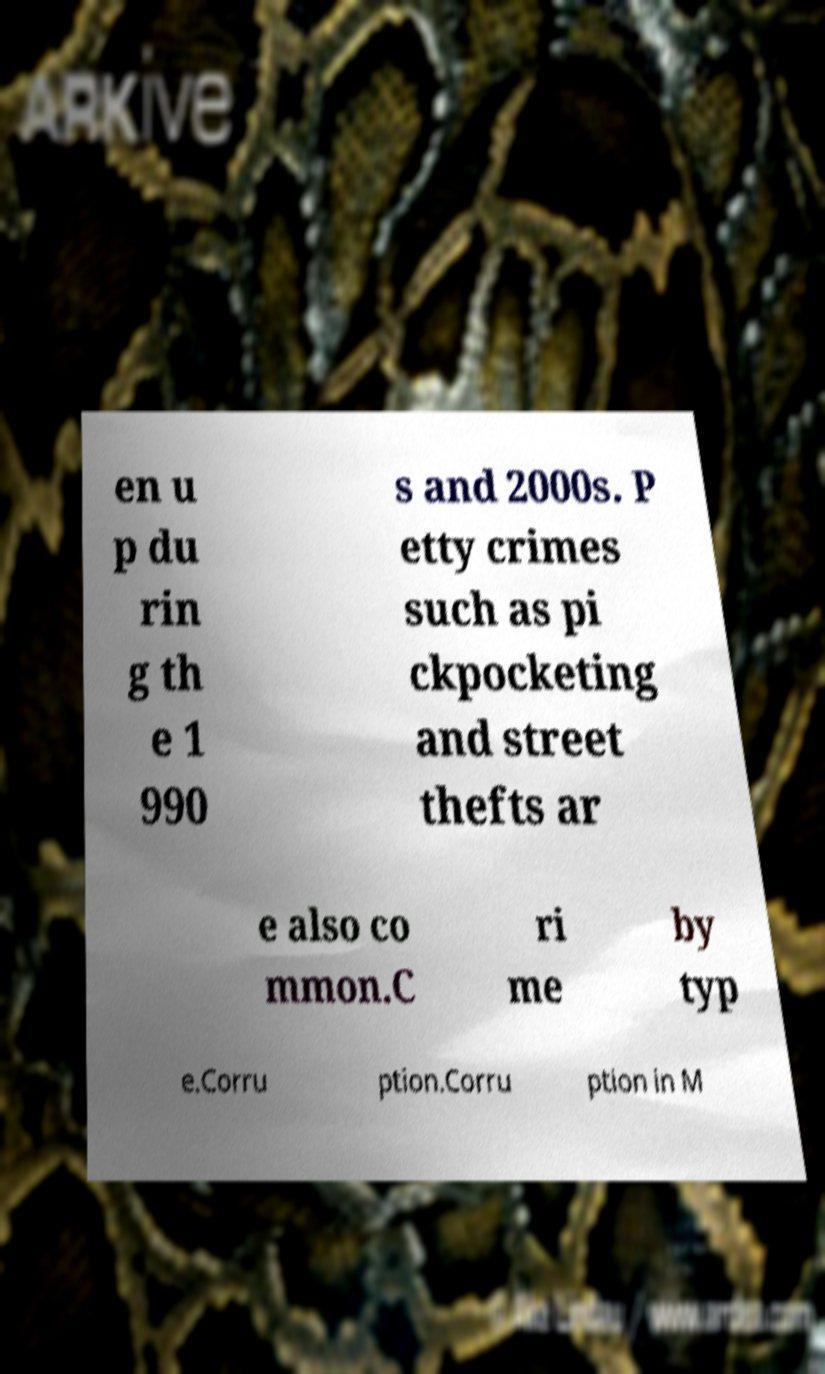Can you read and provide the text displayed in the image?This photo seems to have some interesting text. Can you extract and type it out for me? en u p du rin g th e 1 990 s and 2000s. P etty crimes such as pi ckpocketing and street thefts ar e also co mmon.C ri me by typ e.Corru ption.Corru ption in M 